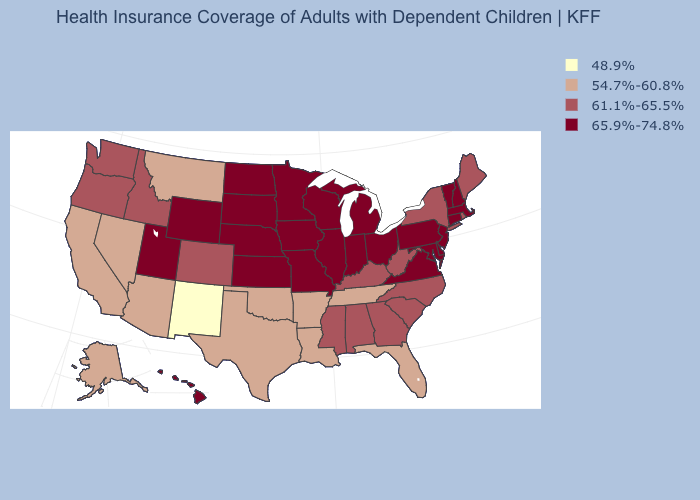What is the highest value in states that border Virginia?
Quick response, please. 65.9%-74.8%. Which states have the lowest value in the USA?
Give a very brief answer. New Mexico. Which states have the lowest value in the USA?
Short answer required. New Mexico. What is the lowest value in the USA?
Give a very brief answer. 48.9%. Among the states that border Connecticut , which have the lowest value?
Quick response, please. New York, Rhode Island. What is the value of Mississippi?
Answer briefly. 61.1%-65.5%. Name the states that have a value in the range 54.7%-60.8%?
Give a very brief answer. Alaska, Arizona, Arkansas, California, Florida, Louisiana, Montana, Nevada, Oklahoma, Tennessee, Texas. What is the value of Maryland?
Concise answer only. 65.9%-74.8%. Does Arkansas have a lower value than Idaho?
Be succinct. Yes. What is the value of New Hampshire?
Give a very brief answer. 65.9%-74.8%. What is the value of New York?
Quick response, please. 61.1%-65.5%. Among the states that border Nebraska , does Wyoming have the highest value?
Write a very short answer. Yes. Does Wyoming have the lowest value in the USA?
Answer briefly. No. What is the value of Alaska?
Answer briefly. 54.7%-60.8%. What is the value of Georgia?
Be succinct. 61.1%-65.5%. 